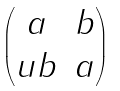<formula> <loc_0><loc_0><loc_500><loc_500>\begin{pmatrix} a & b \\ u b & a \end{pmatrix}</formula> 